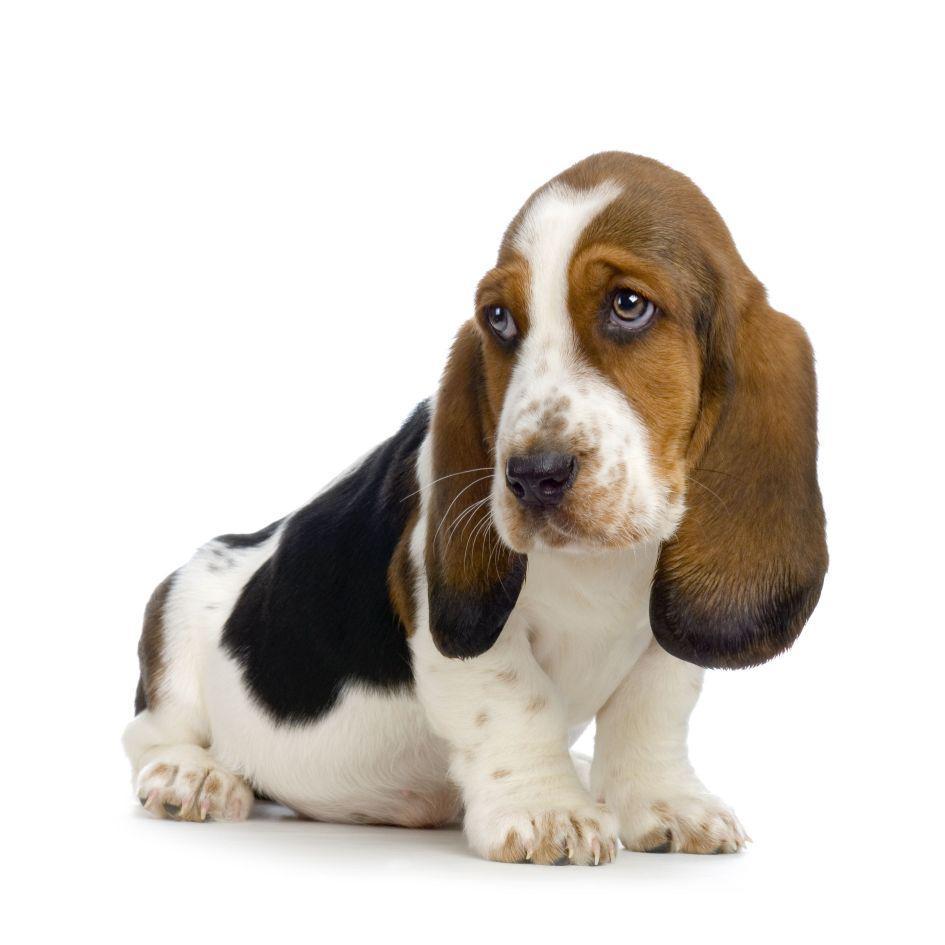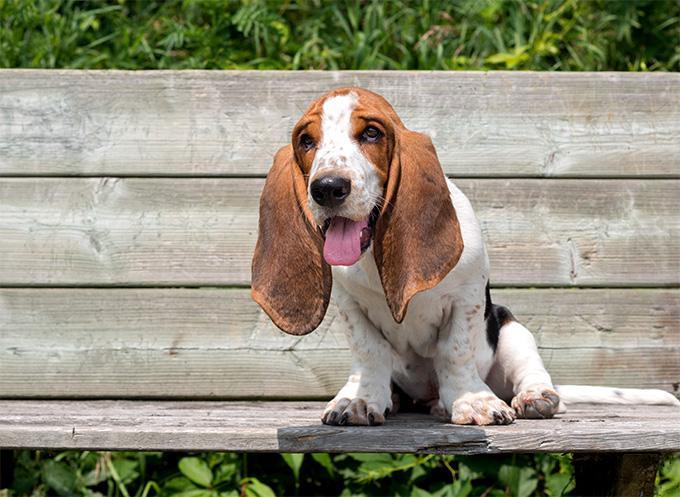The first image is the image on the left, the second image is the image on the right. Assess this claim about the two images: "There are two dogs in total.". Correct or not? Answer yes or no. Yes. 